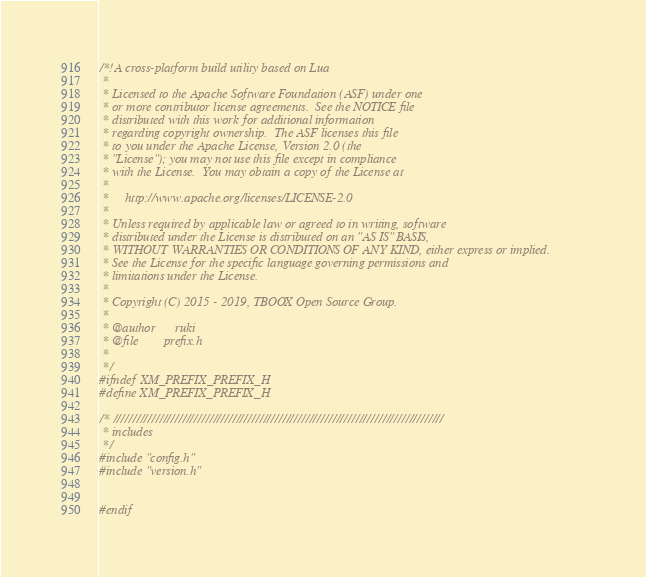<code> <loc_0><loc_0><loc_500><loc_500><_C_>/*!A cross-platform build utility based on Lua
 *
 * Licensed to the Apache Software Foundation (ASF) under one
 * or more contributor license agreements.  See the NOTICE file
 * distributed with this work for additional information
 * regarding copyright ownership.  The ASF licenses this file
 * to you under the Apache License, Version 2.0 (the
 * "License"); you may not use this file except in compliance
 * with the License.  You may obtain a copy of the License at
 *
 *     http://www.apache.org/licenses/LICENSE-2.0
 *
 * Unless required by applicable law or agreed to in writing, software
 * distributed under the License is distributed on an "AS IS" BASIS,
 * WITHOUT WARRANTIES OR CONDITIONS OF ANY KIND, either express or implied.
 * See the License for the specific language governing permissions and
 * limitations under the License.
 * 
 * Copyright (C) 2015 - 2019, TBOOX Open Source Group.
 *
 * @author      ruki
 * @file        prefix.h
 *
 */
#ifndef XM_PREFIX_PREFIX_H
#define XM_PREFIX_PREFIX_H

/* //////////////////////////////////////////////////////////////////////////////////////
 * includes
 */
#include "config.h"
#include "version.h"


#endif


</code> 